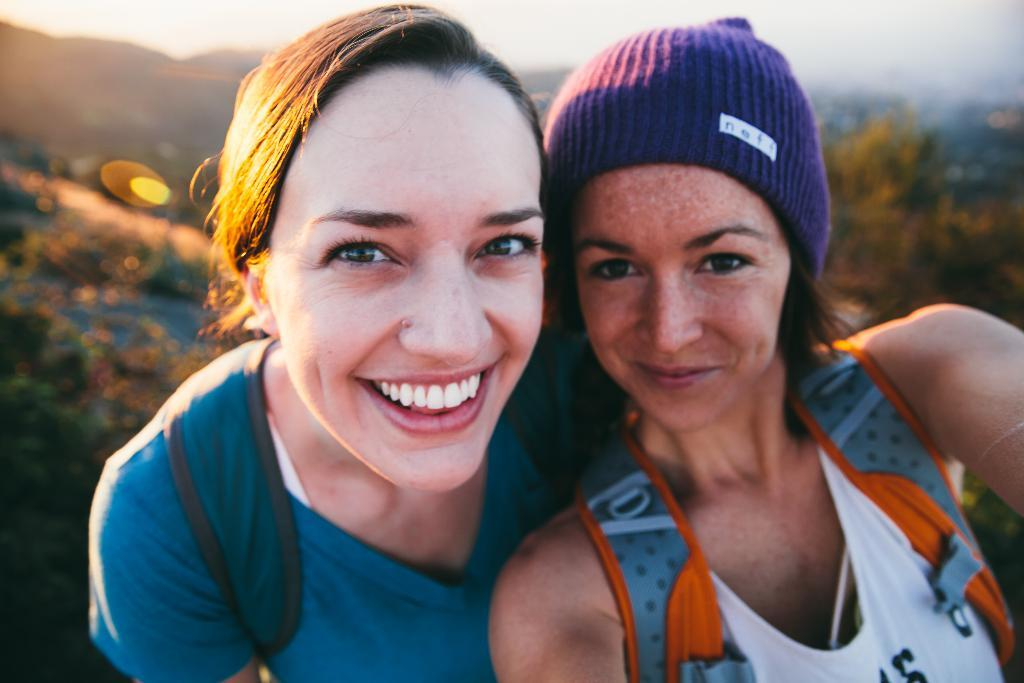How many people are in the image? There are two women in the image. What are the women doing in the image? The women are taking a selfie. What are the women carrying on their backs? Both women are carrying bags on their backs. Can you describe the background of the image? The background of the image is blurred. How much income do the women earn in the image? There is no information about the women's income in the image. What type of eyes can be seen on the women in the image? There is no mention of the women's eyes in the image. 